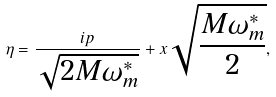<formula> <loc_0><loc_0><loc_500><loc_500>\eta = \frac { i p } { \sqrt { 2 M \omega _ { m } ^ { \ast } } } + x \sqrt { \frac { M \omega _ { m } ^ { \ast } } { 2 } } ,</formula> 